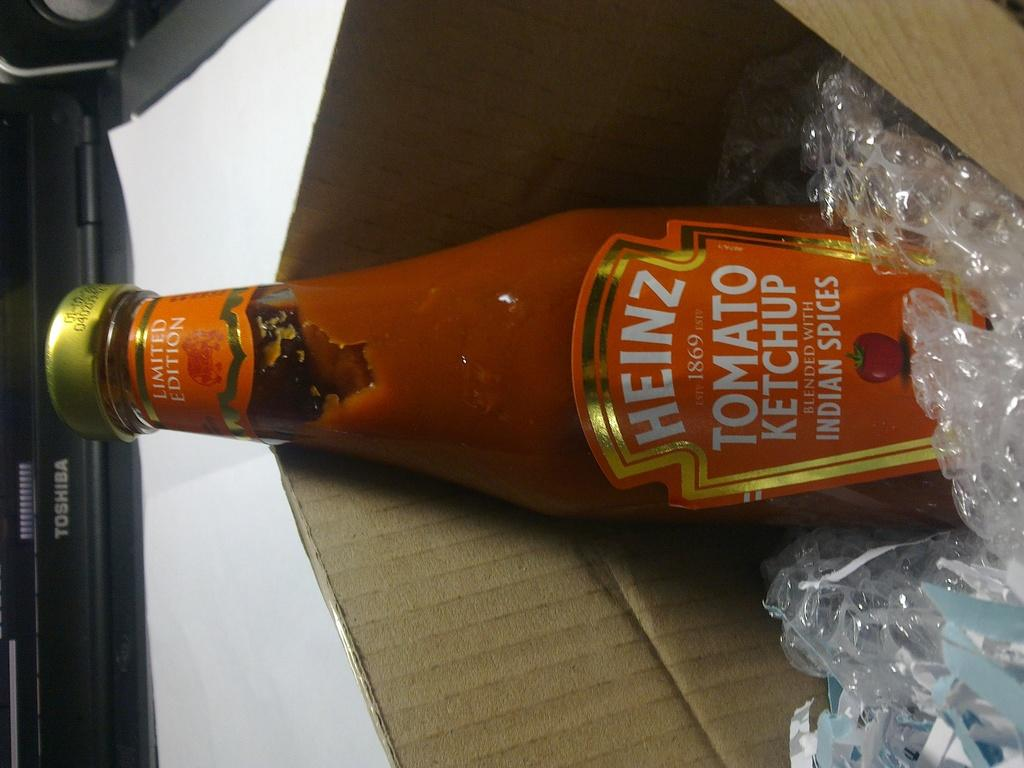<image>
Summarize the visual content of the image. A sideways bottle of Heinz tomato ketchup resting in a box. 